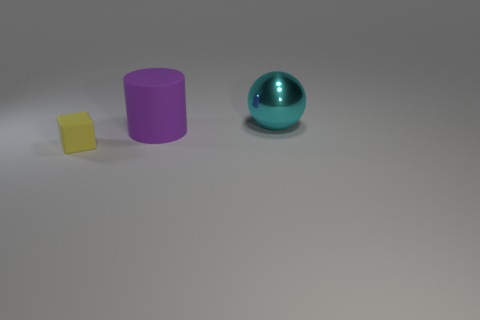Does the large object to the left of the cyan shiny object have the same material as the cyan object? While both objects have a smooth surface suggesting a polished finish, the large object to the left has a matte appearance, whereas the cyan object has a shiny, reflective surface. This suggests that they are likely made of different materials or have different surface treatments. 